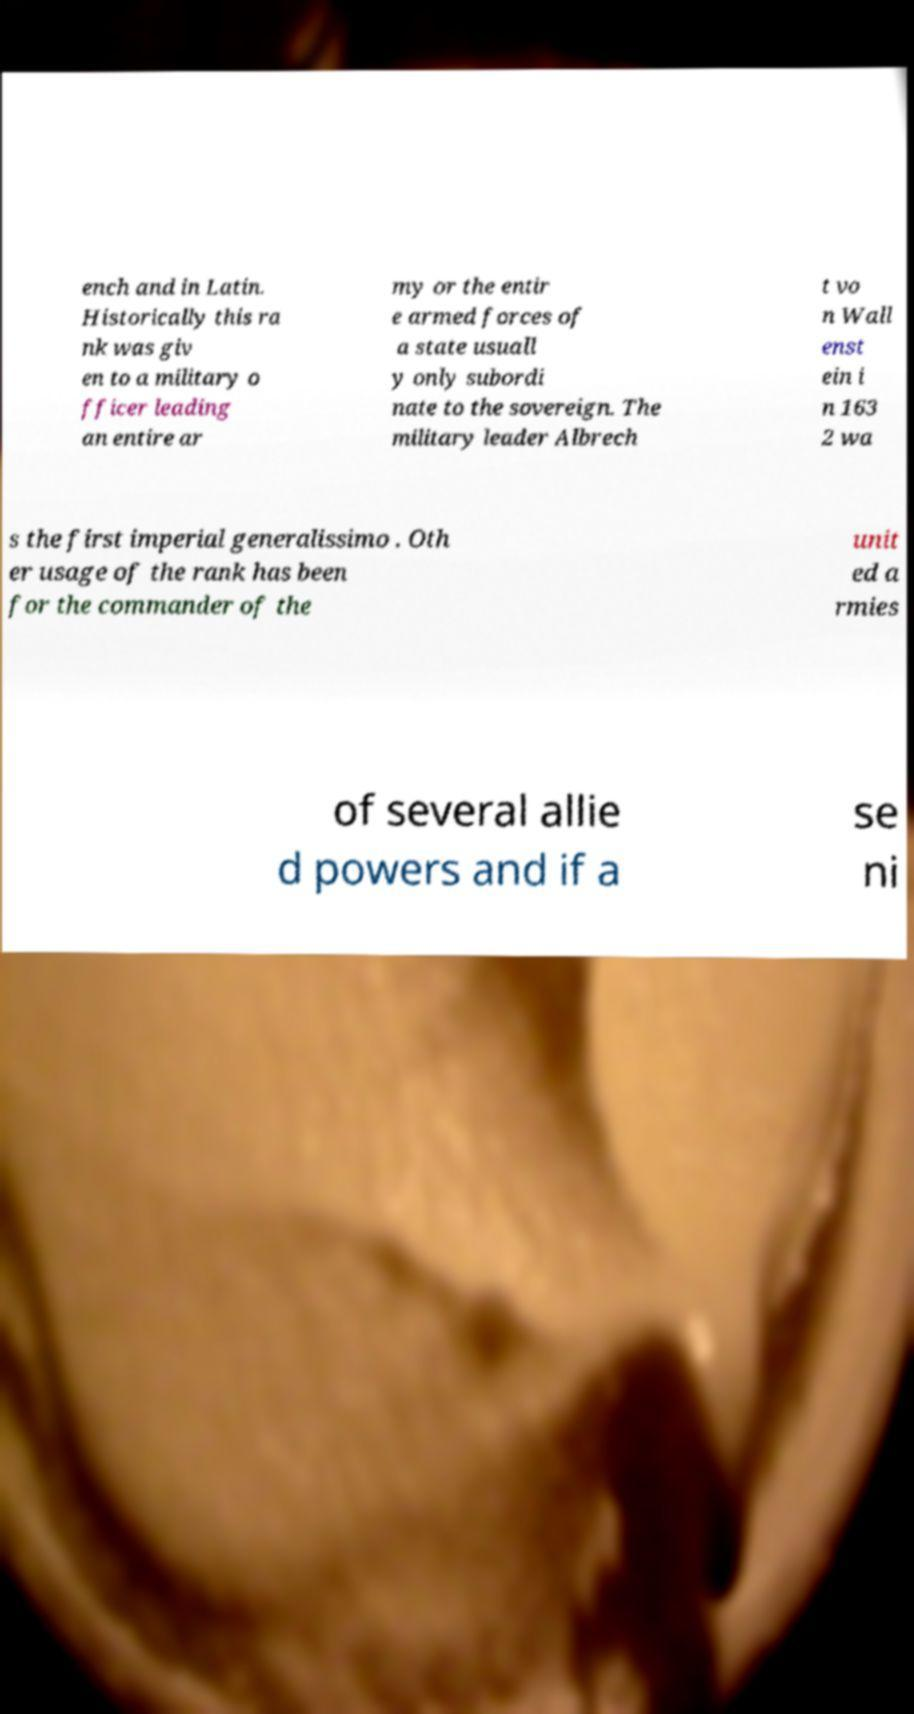Could you assist in decoding the text presented in this image and type it out clearly? ench and in Latin. Historically this ra nk was giv en to a military o fficer leading an entire ar my or the entir e armed forces of a state usuall y only subordi nate to the sovereign. The military leader Albrech t vo n Wall enst ein i n 163 2 wa s the first imperial generalissimo . Oth er usage of the rank has been for the commander of the unit ed a rmies of several allie d powers and if a se ni 